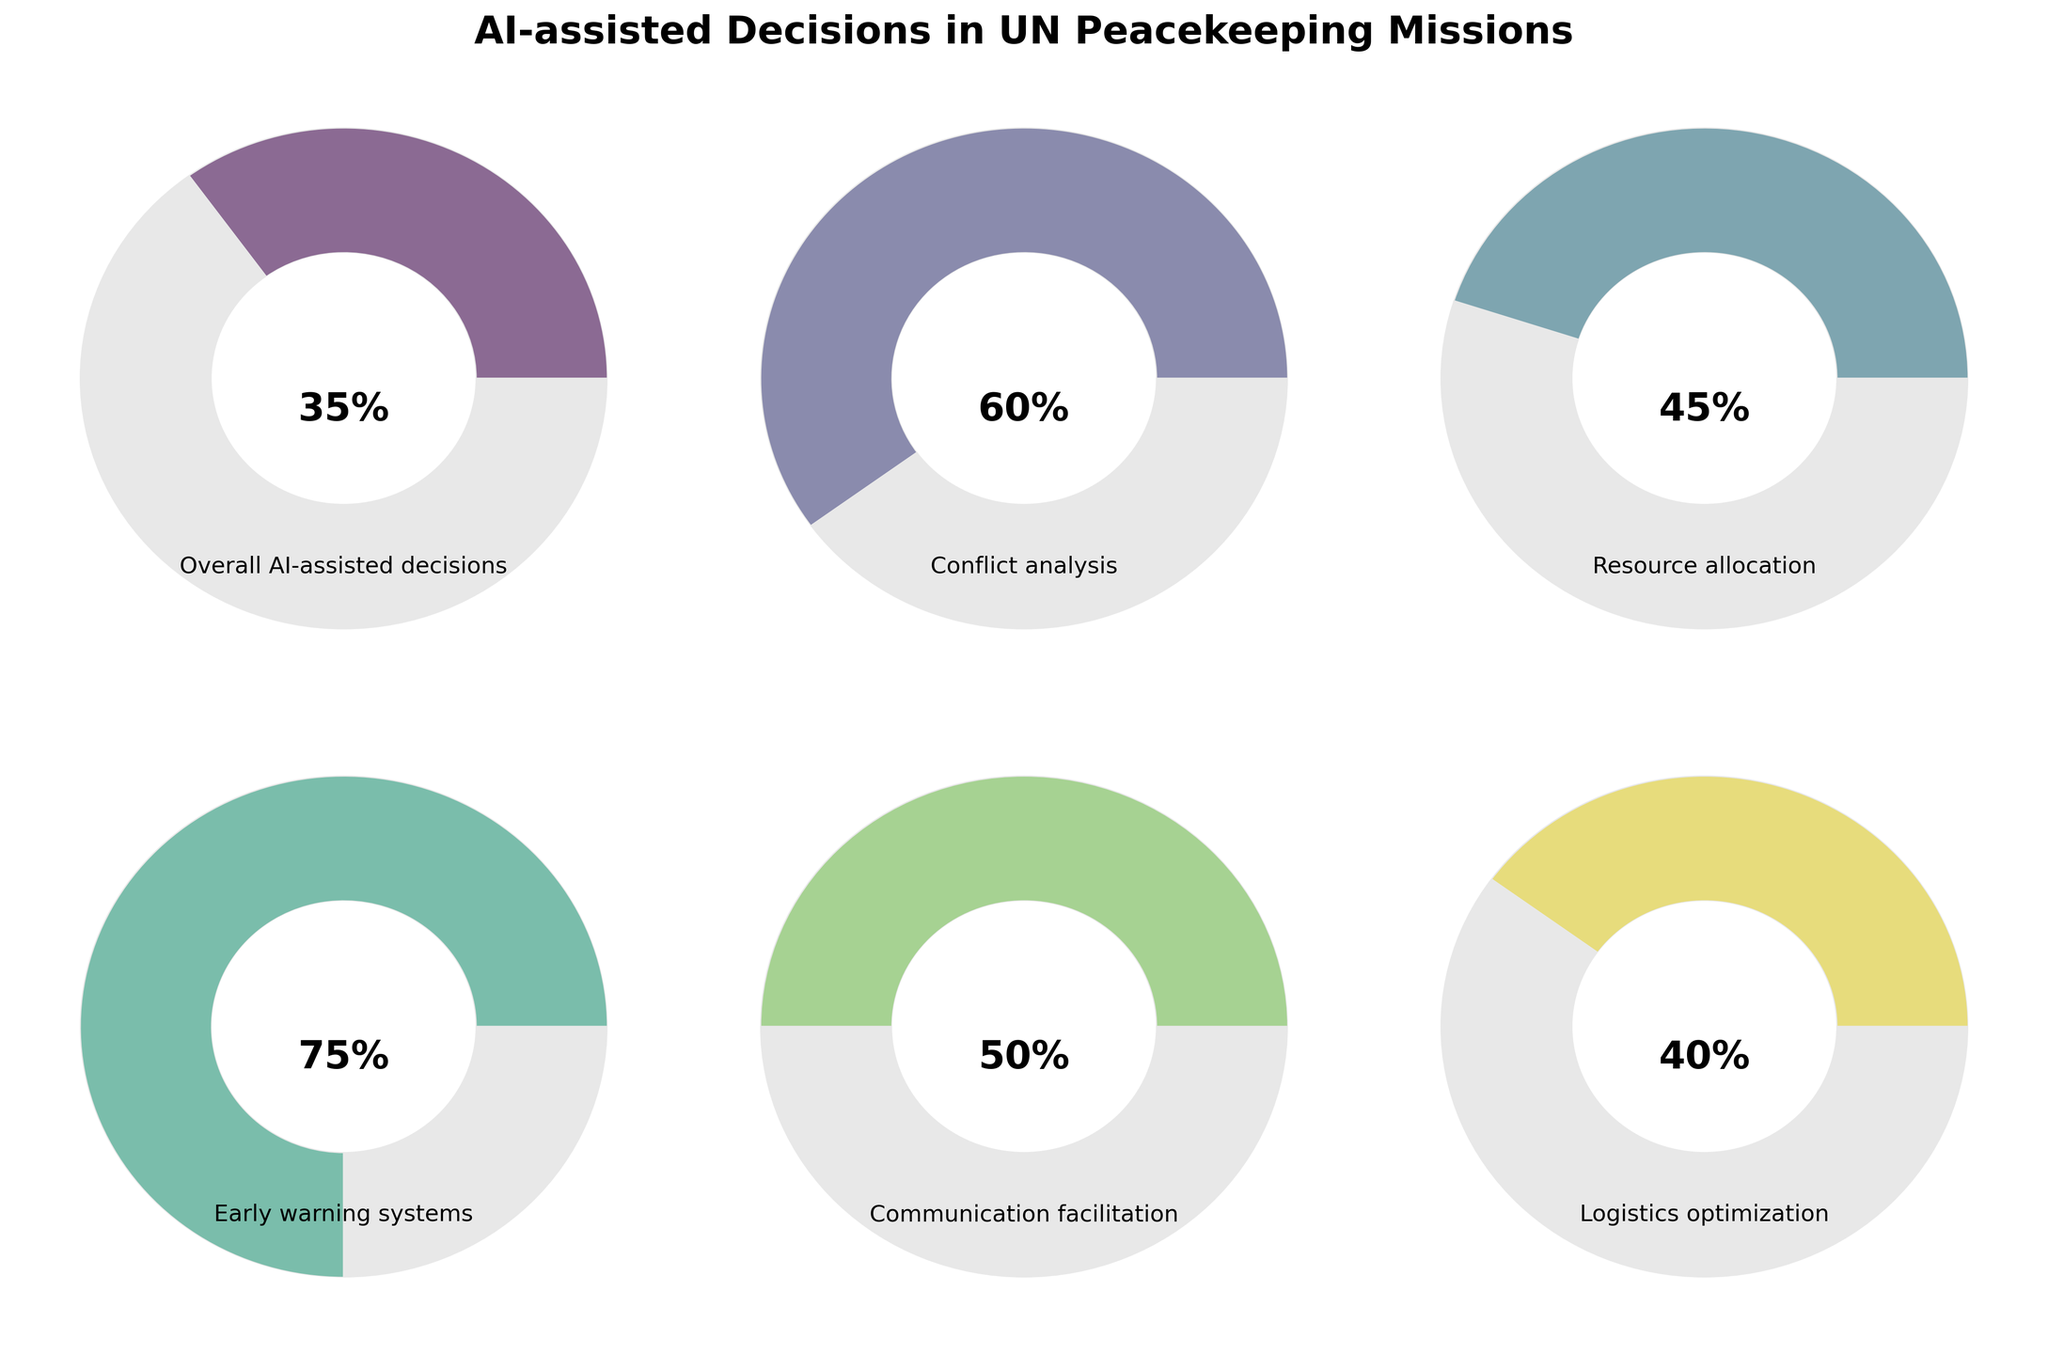What's the title of the figure? The title can be found at the top of the figure, indicating the general subject matter presented in the gauge charts.
Answer: AI-assisted Decisions in UN Peacekeeping Missions Which category has the highest percentage of AI-assisted decisions? To answer this, identify the category with the highest percentage value in the visual representation of the gauge charts.
Answer: Early warning systems How many categories have a percentage of AI-assisted decisions greater than 50%? Check each gauge chart and count the ones where the percentage value exceeds 50%.
Answer: 3 Which category has the lowest percentage of AI-assisted decisions? Identify the category with the smallest percentage value among the gauge charts presented.
Answer: Overall AI-assisted decisions What's the combined percentage of AI-assisted decisions for Resource allocation and Logistics optimization? Add the percentages of the two specified categories (Resource allocation and Logistics optimization).
Answer: 85% How much higher is the percentage for Communication facilitation compared to Logistics optimization? Subtract the percentage of Logistics optimization from the percentage of Communication facilitation.
Answer: 10% Which category has a percentage exactly halfway between Resource allocation and Early warning systems? Calculate the average of Resource allocation and Early warning systems percentages, and compare this with the other categories.
Answer: Communication facilitation What is the difference in percentage between Conflict analysis and Overall AI-assisted decisions? Subtract the percentage of Overall AI-assisted decisions from the percentage of Conflict analysis.
Answer: 25% Which categories have a percentage within 10% of the Overall AI-assisted decisions? Analyze each category and see if their percentages fall within the range of 25% to 45% (35% ± 10%).
Answer: Resource allocation, Logistics optimization 